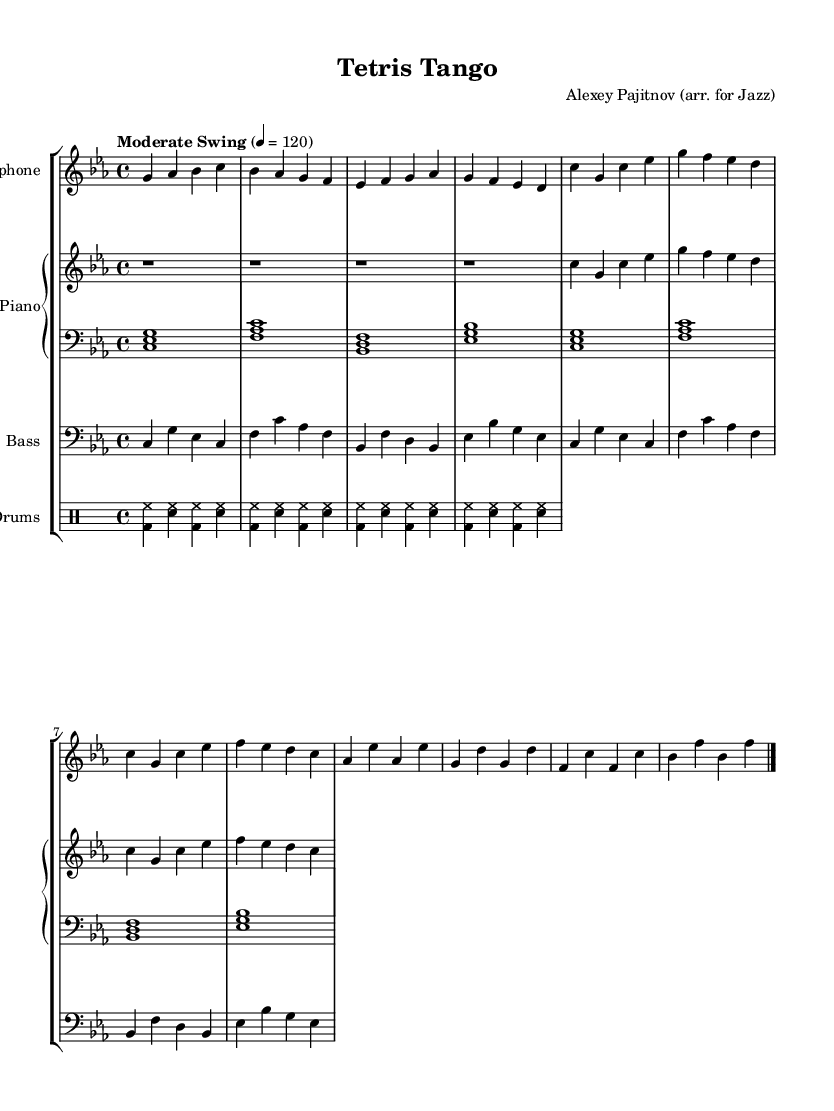What is the key signature of this music? The key signature is C minor, which has three flats: B flat, E flat, and A flat.
Answer: C minor What is the time signature of the piece? The time signature is 4/4, indicating four beats per measure with a quarter note getting one beat.
Answer: 4/4 What is the tempo marking for this piece? The tempo marking indicates "Moderate Swing" at a speed of 120 beats per minute, suggesting a relaxed and jazzy feel.
Answer: Moderate Swing, 120 Which instrument has the treble clef in the score? The saxophone and the right hand of the piano are both written in treble clef, allowing them to play higher-pitched notes.
Answer: Saxophone, Piano Right Hand How many measures are in Theme A? Theme A consists of four measures, which are clearly notated in the sheet music.
Answer: 4 measures What style of rhythm is indicated for the drum part? The drum part shows a basic swing pattern, which is characterized by a unique "triplet feel" common in jazz music.
Answer: Swing What is unique about the bass line compared to the piano? The bass line has a walking pattern that is designed to provide a continuous pulse, whereas the piano comping provides harmonic support.
Answer: Walking bass line 